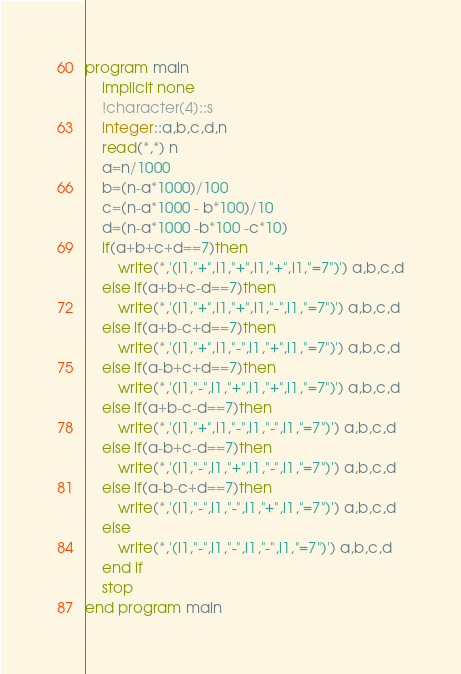<code> <loc_0><loc_0><loc_500><loc_500><_FORTRAN_>program main
	implicit none
    !character(4)::s
    integer::a,b,c,d,n
    read(*,*) n
    a=n/1000
    b=(n-a*1000)/100
    c=(n-a*1000 - b*100)/10
    d=(n-a*1000 -b*100 -c*10)
    if(a+b+c+d==7)then
    	write(*,'(i1,"+",i1,"+",i1,"+",i1,"=7")') a,b,c,d
    else if(a+b+c-d==7)then
    	write(*,'(i1,"+",i1,"+",i1,"-",i1,"=7")') a,b,c,d
    else if(a+b-c+d==7)then
    	write(*,'(i1,"+",i1,"-",i1,"+",i1,"=7")') a,b,c,d
    else if(a-b+c+d==7)then
    	write(*,'(i1,"-",i1,"+",i1,"+",i1,"=7")') a,b,c,d
    else if(a+b-c-d==7)then
    	write(*,'(i1,"+",i1,"-",i1,"-",i1,"=7")') a,b,c,d
    else if(a-b+c-d==7)then
    	write(*,'(i1,"-",i1,"+",i1,"-",i1,"=7")') a,b,c,d
    else if(a-b-c+d==7)then
    	write(*,'(i1,"-",i1,"-",i1,"+",i1,"=7")') a,b,c,d
    else
    	write(*,'(i1,"-",i1,"-",i1,"-",i1,"=7")') a,b,c,d
    end if
    stop
end program main</code> 